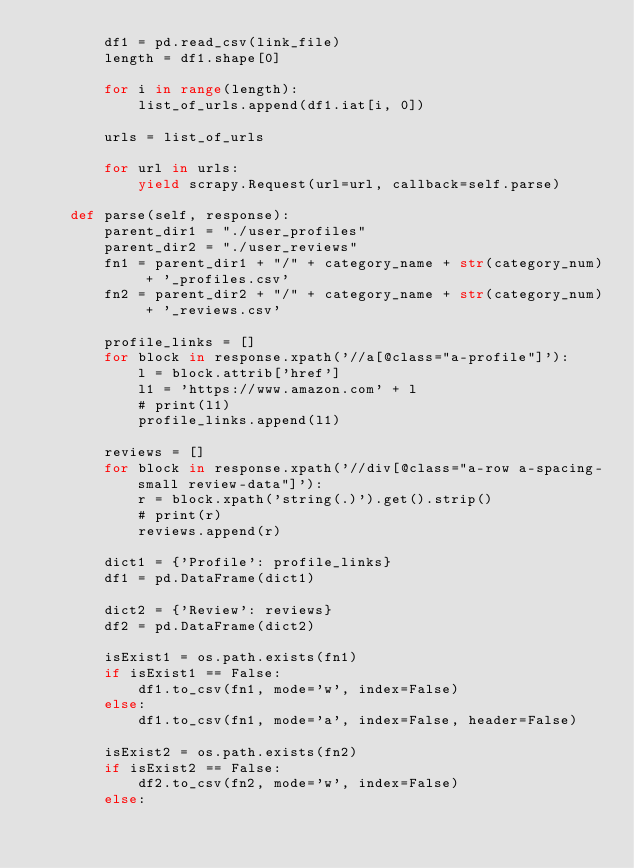<code> <loc_0><loc_0><loc_500><loc_500><_Python_>        df1 = pd.read_csv(link_file)
        length = df1.shape[0]

        for i in range(length):
            list_of_urls.append(df1.iat[i, 0])
        
        urls = list_of_urls

        for url in urls:
            yield scrapy.Request(url=url, callback=self.parse)

    def parse(self, response):
        parent_dir1 = "./user_profiles"
        parent_dir2 = "./user_reviews"
        fn1 = parent_dir1 + "/" + category_name + str(category_num) + '_profiles.csv'
        fn2 = parent_dir2 + "/" + category_name + str(category_num) + '_reviews.csv'

        profile_links = []
        for block in response.xpath('//a[@class="a-profile"]'):
            l = block.attrib['href']
            l1 = 'https://www.amazon.com' + l
            # print(l1)
            profile_links.append(l1)

        reviews = []
        for block in response.xpath('//div[@class="a-row a-spacing-small review-data"]'):
            r = block.xpath('string(.)').get().strip()
            # print(r)
            reviews.append(r)
        
        dict1 = {'Profile': profile_links}
        df1 = pd.DataFrame(dict1)

        dict2 = {'Review': reviews}
        df2 = pd.DataFrame(dict2)

        isExist1 = os.path.exists(fn1)
        if isExist1 == False:
            df1.to_csv(fn1, mode='w', index=False)
        else:
            df1.to_csv(fn1, mode='a', index=False, header=False)

        isExist2 = os.path.exists(fn2)
        if isExist2 == False:
            df2.to_csv(fn2, mode='w', index=False)
        else:</code> 